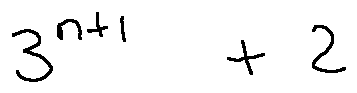<formula> <loc_0><loc_0><loc_500><loc_500>3 ^ { n + 1 } + 2</formula> 